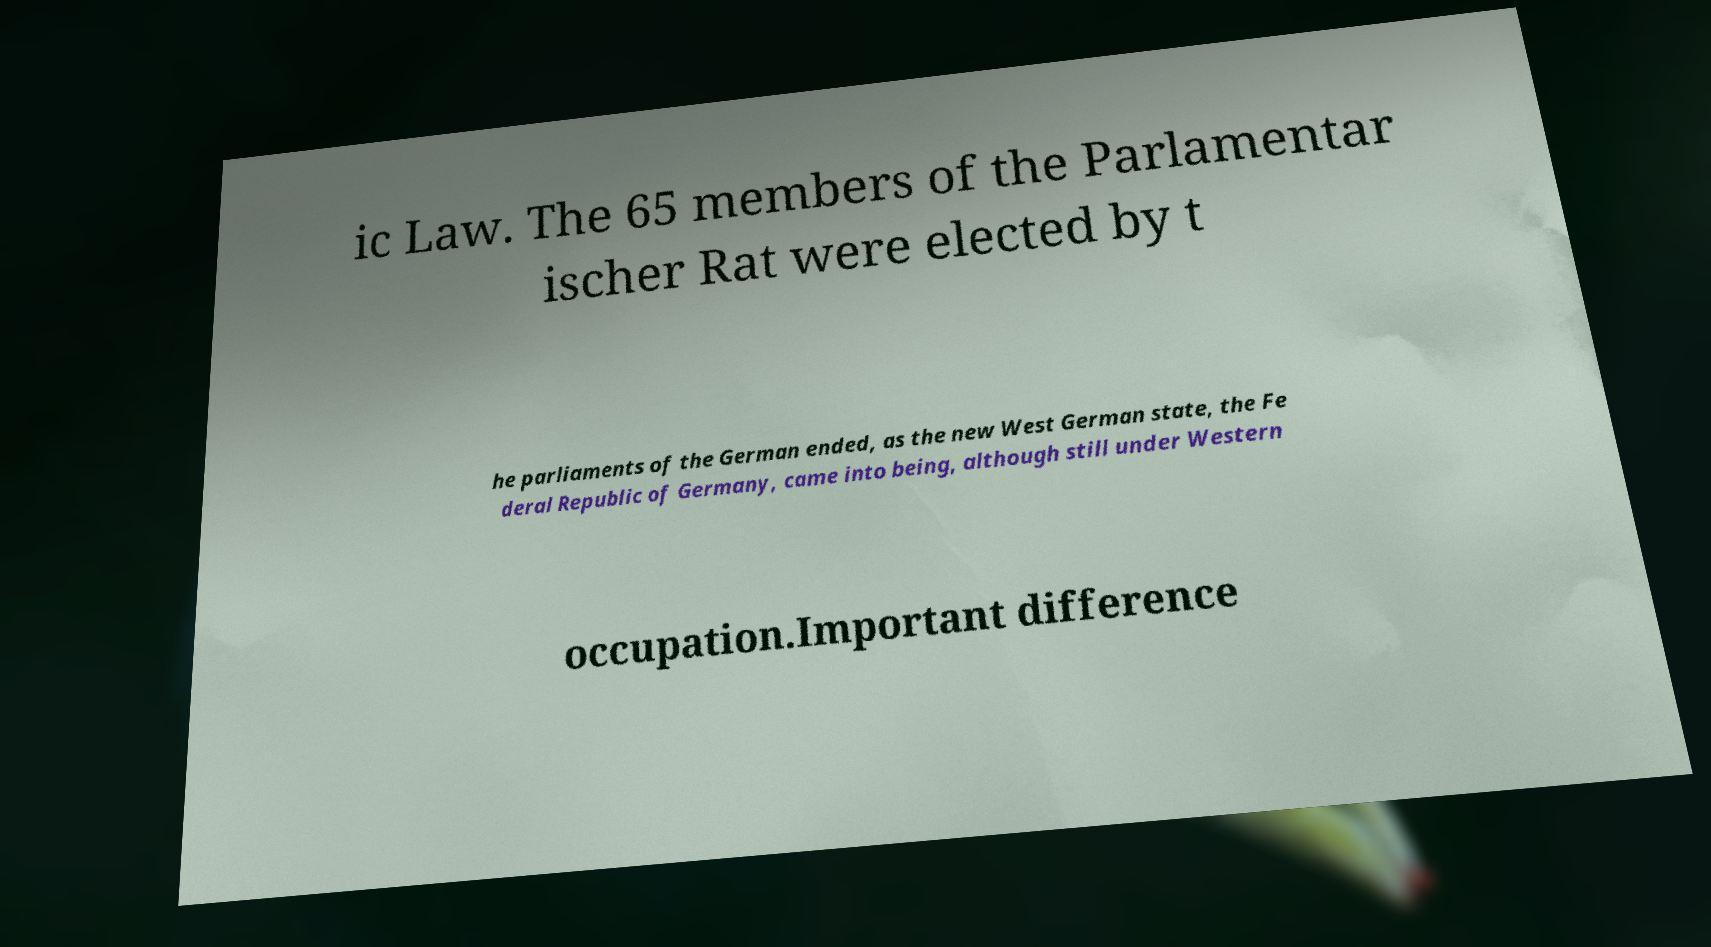Please identify and transcribe the text found in this image. ic Law. The 65 members of the Parlamentar ischer Rat were elected by t he parliaments of the German ended, as the new West German state, the Fe deral Republic of Germany, came into being, although still under Western occupation.Important difference 